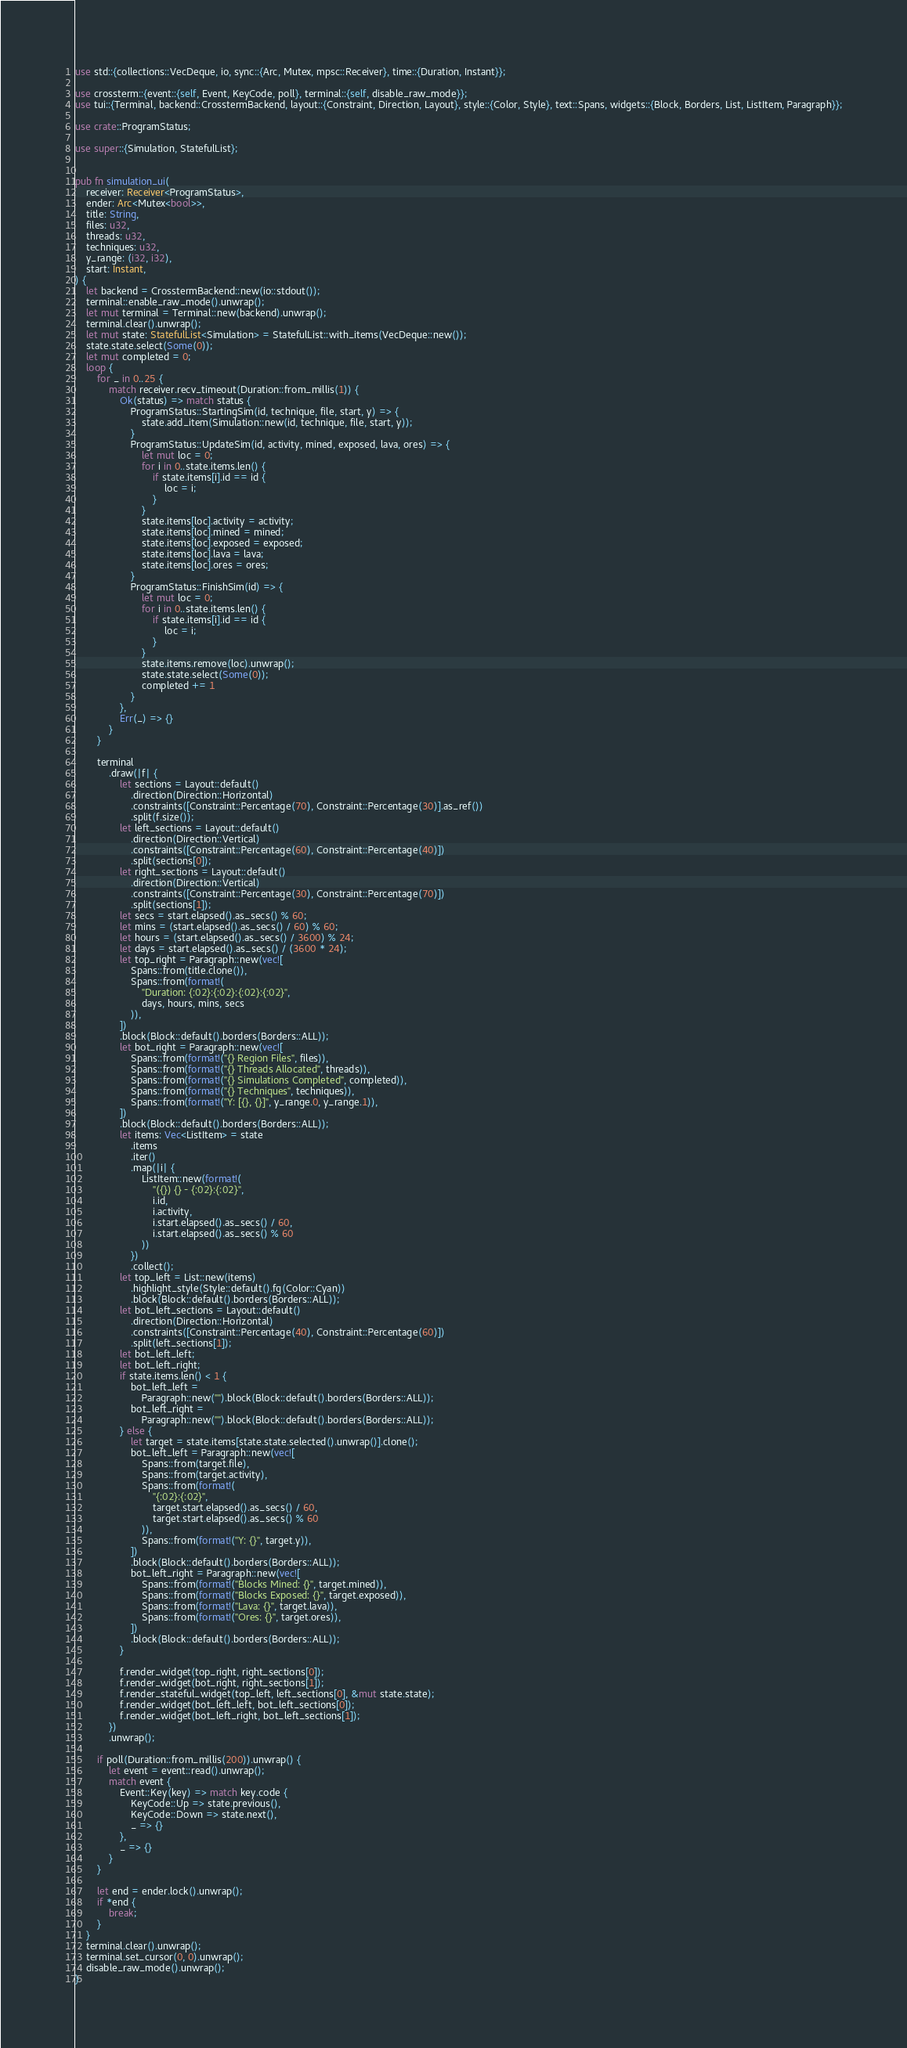Convert code to text. <code><loc_0><loc_0><loc_500><loc_500><_Rust_>use std::{collections::VecDeque, io, sync::{Arc, Mutex, mpsc::Receiver}, time::{Duration, Instant}};

use crossterm::{event::{self, Event, KeyCode, poll}, terminal::{self, disable_raw_mode}};
use tui::{Terminal, backend::CrosstermBackend, layout::{Constraint, Direction, Layout}, style::{Color, Style}, text::Spans, widgets::{Block, Borders, List, ListItem, Paragraph}};

use crate::ProgramStatus;

use super::{Simulation, StatefulList};


pub fn simulation_ui(
    receiver: Receiver<ProgramStatus>,
    ender: Arc<Mutex<bool>>,
    title: String,
    files: u32,
    threads: u32,
    techniques: u32,
    y_range: (i32, i32),
    start: Instant,
) {
    let backend = CrosstermBackend::new(io::stdout());
    terminal::enable_raw_mode().unwrap();
    let mut terminal = Terminal::new(backend).unwrap();
    terminal.clear().unwrap();
    let mut state: StatefulList<Simulation> = StatefulList::with_items(VecDeque::new());
    state.state.select(Some(0));
    let mut completed = 0;
    loop {
        for _ in 0..25 {
            match receiver.recv_timeout(Duration::from_millis(1)) {
                Ok(status) => match status {
                    ProgramStatus::StartingSim(id, technique, file, start, y) => {
                        state.add_item(Simulation::new(id, technique, file, start, y));
                    }
                    ProgramStatus::UpdateSim(id, activity, mined, exposed, lava, ores) => {
                        let mut loc = 0;
                        for i in 0..state.items.len() {
                            if state.items[i].id == id {
                                loc = i;
                            }
                        }
                        state.items[loc].activity = activity;
                        state.items[loc].mined = mined;
                        state.items[loc].exposed = exposed;
                        state.items[loc].lava = lava;
                        state.items[loc].ores = ores;
                    }
                    ProgramStatus::FinishSim(id) => {
                        let mut loc = 0;
                        for i in 0..state.items.len() {
                            if state.items[i].id == id {
                                loc = i;
                            }
                        }
                        state.items.remove(loc).unwrap();
                        state.state.select(Some(0));
                        completed += 1
                    }
                },
                Err(_) => {}
            }
        }

        terminal
            .draw(|f| {
                let sections = Layout::default()
                    .direction(Direction::Horizontal)
                    .constraints([Constraint::Percentage(70), Constraint::Percentage(30)].as_ref())
                    .split(f.size());
                let left_sections = Layout::default()
                    .direction(Direction::Vertical)
                    .constraints([Constraint::Percentage(60), Constraint::Percentage(40)])
                    .split(sections[0]);
                let right_sections = Layout::default()
                    .direction(Direction::Vertical)
                    .constraints([Constraint::Percentage(30), Constraint::Percentage(70)])
                    .split(sections[1]);
                let secs = start.elapsed().as_secs() % 60;
                let mins = (start.elapsed().as_secs() / 60) % 60;
                let hours = (start.elapsed().as_secs() / 3600) % 24;
                let days = start.elapsed().as_secs() / (3600 * 24);
                let top_right = Paragraph::new(vec![
                    Spans::from(title.clone()),
                    Spans::from(format!(
                        "Duration: {:02}:{:02}:{:02}:{:02}",
                        days, hours, mins, secs
                    )),
                ])
                .block(Block::default().borders(Borders::ALL));
                let bot_right = Paragraph::new(vec![
                    Spans::from(format!("{} Region Files", files)),
                    Spans::from(format!("{} Threads Allocated", threads)),
                    Spans::from(format!("{} Simulations Completed", completed)),
                    Spans::from(format!("{} Techniques", techniques)),
                    Spans::from(format!("Y: [{}, {}]", y_range.0, y_range.1)),
                ])
                .block(Block::default().borders(Borders::ALL));
                let items: Vec<ListItem> = state
                    .items
                    .iter()
                    .map(|i| {
                        ListItem::new(format!(
                            "({}) {} - {:02}:{:02}",
                            i.id,
                            i.activity,
                            i.start.elapsed().as_secs() / 60,
                            i.start.elapsed().as_secs() % 60
                        ))
                    })
                    .collect();
                let top_left = List::new(items)
                    .highlight_style(Style::default().fg(Color::Cyan))
                    .block(Block::default().borders(Borders::ALL));
                let bot_left_sections = Layout::default()
                    .direction(Direction::Horizontal)
                    .constraints([Constraint::Percentage(40), Constraint::Percentage(60)])
                    .split(left_sections[1]);
                let bot_left_left;
                let bot_left_right;
                if state.items.len() < 1 {
                    bot_left_left =
                        Paragraph::new("").block(Block::default().borders(Borders::ALL));
                    bot_left_right =
                        Paragraph::new("").block(Block::default().borders(Borders::ALL));
                } else {
                    let target = state.items[state.state.selected().unwrap()].clone();
                    bot_left_left = Paragraph::new(vec![
                        Spans::from(target.file),
                        Spans::from(target.activity),
                        Spans::from(format!(
                            "{:02}:{:02}",
                            target.start.elapsed().as_secs() / 60,
                            target.start.elapsed().as_secs() % 60
                        )),
                        Spans::from(format!("Y: {}", target.y)),
                    ])
                    .block(Block::default().borders(Borders::ALL));
                    bot_left_right = Paragraph::new(vec![
                        Spans::from(format!("Blocks Mined: {}", target.mined)),
                        Spans::from(format!("Blocks Exposed: {}", target.exposed)),
                        Spans::from(format!("Lava: {}", target.lava)),
                        Spans::from(format!("Ores: {}", target.ores)),
                    ])
                    .block(Block::default().borders(Borders::ALL));
                }

                f.render_widget(top_right, right_sections[0]);
                f.render_widget(bot_right, right_sections[1]);
                f.render_stateful_widget(top_left, left_sections[0], &mut state.state);
                f.render_widget(bot_left_left, bot_left_sections[0]);
                f.render_widget(bot_left_right, bot_left_sections[1]);
            })
            .unwrap();

        if poll(Duration::from_millis(200)).unwrap() {
            let event = event::read().unwrap();
            match event {
                Event::Key(key) => match key.code {
                    KeyCode::Up => state.previous(),
                    KeyCode::Down => state.next(),
                    _ => {}
                },
                _ => {}
            }
        }

        let end = ender.lock().unwrap();
        if *end {
            break;
        }
    }
    terminal.clear().unwrap();
    terminal.set_cursor(0, 0).unwrap();
    disable_raw_mode().unwrap();
}</code> 